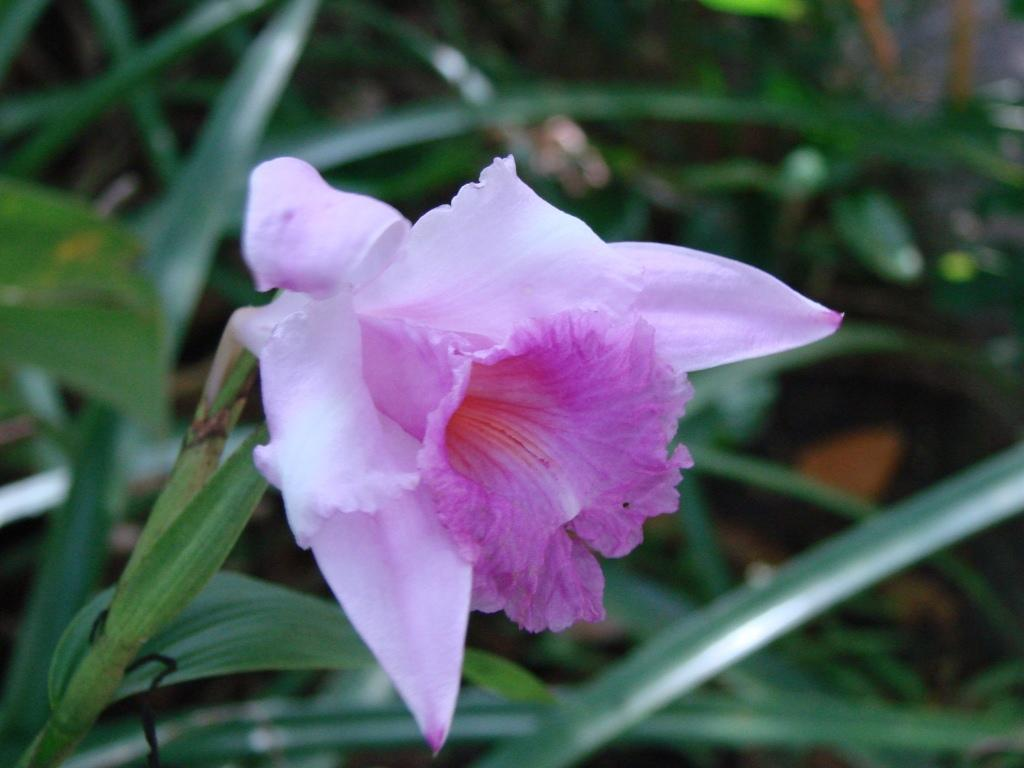What type of flower is in the image? There is a pink flower in the image. Is the flower part of a larger plant? Yes, the flower is part of a plant. What color is the background behind the flower? The background of the flower is blue. What type of drug is being administered to the flower in the image? There is no drug being administered to the flower in the image; it is a still image of a flower. 